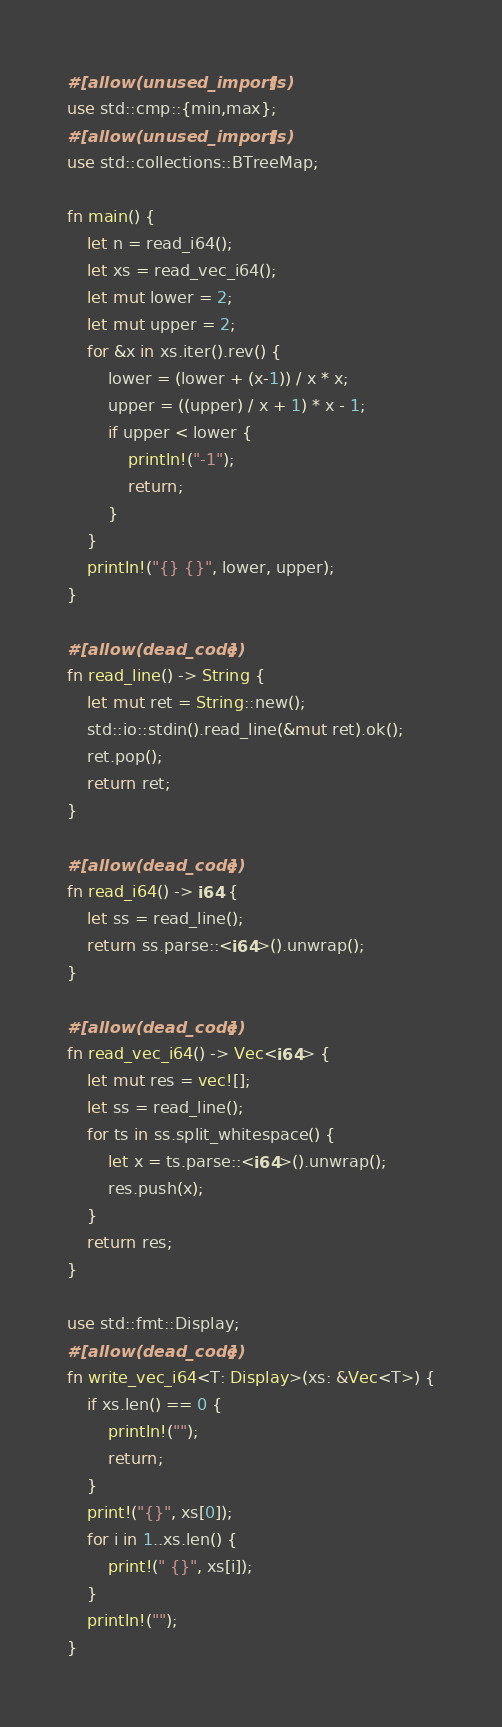<code> <loc_0><loc_0><loc_500><loc_500><_Rust_>#[allow(unused_imports)]
use std::cmp::{min,max};
#[allow(unused_imports)]
use std::collections::BTreeMap;

fn main() {
    let n = read_i64();
    let xs = read_vec_i64();
    let mut lower = 2;
    let mut upper = 2;
    for &x in xs.iter().rev() {
        lower = (lower + (x-1)) / x * x;
        upper = ((upper) / x + 1) * x - 1;
        if upper < lower {
            println!("-1");
            return;
        }
    }
    println!("{} {}", lower, upper);
}

#[allow(dead_code)]
fn read_line() -> String {
    let mut ret = String::new();
    std::io::stdin().read_line(&mut ret).ok();
    ret.pop();
    return ret;
}

#[allow(dead_code)]
fn read_i64() -> i64 {
    let ss = read_line();
    return ss.parse::<i64>().unwrap();
}

#[allow(dead_code)]
fn read_vec_i64() -> Vec<i64> {
    let mut res = vec![];
    let ss = read_line();
    for ts in ss.split_whitespace() {
        let x = ts.parse::<i64>().unwrap();
        res.push(x);
    }
    return res;
}

use std::fmt::Display;
#[allow(dead_code)]
fn write_vec_i64<T: Display>(xs: &Vec<T>) {
    if xs.len() == 0 {
        println!("");
        return;
    }
    print!("{}", xs[0]);
    for i in 1..xs.len() {
        print!(" {}", xs[i]);
    }
    println!("");
}
</code> 